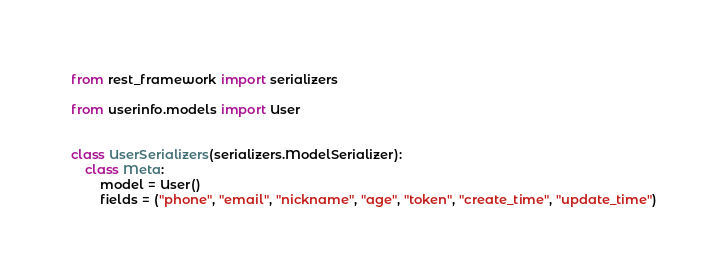Convert code to text. <code><loc_0><loc_0><loc_500><loc_500><_Python_>from rest_framework import serializers

from userinfo.models import User


class UserSerializers(serializers.ModelSerializer):
    class Meta:
        model = User()
        fields = ("phone", "email", "nickname", "age", "token", "create_time", "update_time")
</code> 